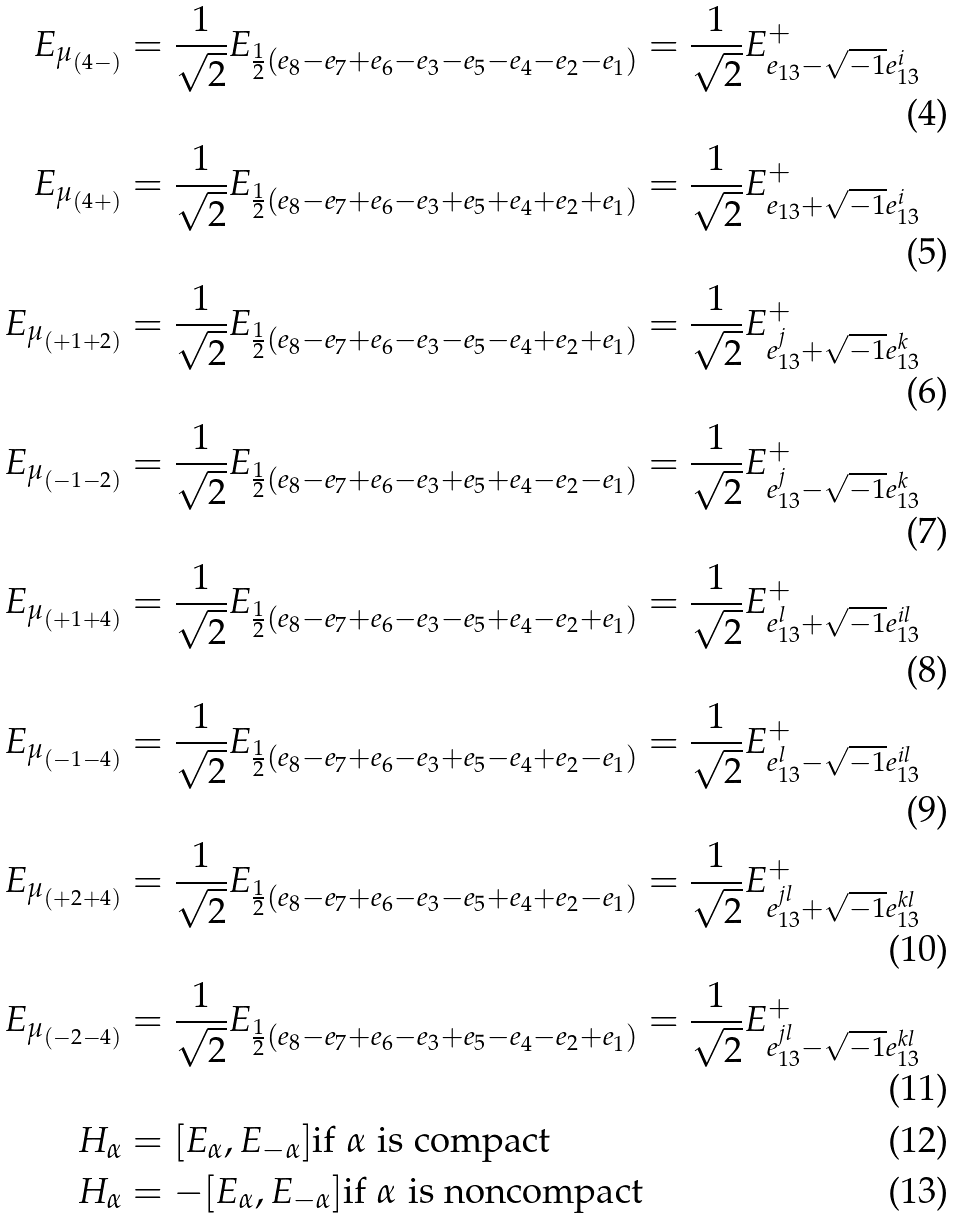<formula> <loc_0><loc_0><loc_500><loc_500>E _ { \mu _ { ( 4 - ) } } & = \frac { 1 } { \sqrt { 2 } } E _ { \frac { 1 } { 2 } ( e _ { 8 } - e _ { 7 } + e _ { 6 } - e _ { 3 } - e _ { 5 } - e _ { 4 } - e _ { 2 } - e _ { 1 } ) } = \frac { 1 } { \sqrt { 2 } } E _ { e _ { 1 3 } - \sqrt { - 1 } e _ { 1 3 } ^ { i } } ^ { + } \\ E _ { \mu _ { ( 4 + ) } } & = \frac { 1 } { \sqrt { 2 } } E _ { \frac { 1 } { 2 } ( e _ { 8 } - e _ { 7 } + e _ { 6 } - e _ { 3 } + e _ { 5 } + e _ { 4 } + e _ { 2 } + e _ { 1 } ) } = \frac { 1 } { \sqrt { 2 } } E _ { e _ { 1 3 } + \sqrt { - 1 } e _ { 1 3 } ^ { i } } ^ { + } \\ E _ { \mu _ { ( + 1 + 2 ) } } & = \frac { 1 } { \sqrt { 2 } } E _ { \frac { 1 } { 2 } ( e _ { 8 } - e _ { 7 } + e _ { 6 } - e _ { 3 } - e _ { 5 } - e _ { 4 } + e _ { 2 } + e _ { 1 } ) } = \frac { 1 } { \sqrt { 2 } } E _ { e _ { 1 3 } ^ { j } + \sqrt { - 1 } e _ { 1 3 } ^ { k } } ^ { + } \\ E _ { \mu _ { ( - 1 - 2 ) } } & = \frac { 1 } { \sqrt { 2 } } E _ { \frac { 1 } { 2 } ( e _ { 8 } - e _ { 7 } + e _ { 6 } - e _ { 3 } + e _ { 5 } + e _ { 4 } - e _ { 2 } - e _ { 1 } ) } = \frac { 1 } { \sqrt { 2 } } E _ { e _ { 1 3 } ^ { j } - \sqrt { - 1 } e _ { 1 3 } ^ { k } } ^ { + } \\ E _ { \mu _ { ( + 1 + 4 ) } } & = \frac { 1 } { \sqrt { 2 } } E _ { \frac { 1 } { 2 } ( e _ { 8 } - e _ { 7 } + e _ { 6 } - e _ { 3 } - e _ { 5 } + e _ { 4 } - e _ { 2 } + e _ { 1 } ) } = \frac { 1 } { \sqrt { 2 } } E _ { e _ { 1 3 } ^ { l } + \sqrt { - 1 } e _ { 1 3 } ^ { i l } } ^ { + } \\ E _ { \mu _ { ( - 1 - 4 ) } } & = \frac { 1 } { \sqrt { 2 } } E _ { \frac { 1 } { 2 } ( e _ { 8 } - e _ { 7 } + e _ { 6 } - e _ { 3 } + e _ { 5 } - e _ { 4 } + e _ { 2 } - e _ { 1 } ) } = \frac { 1 } { \sqrt { 2 } } E _ { e _ { 1 3 } ^ { l } - \sqrt { - 1 } e _ { 1 3 } ^ { i l } } ^ { + } \\ E _ { \mu _ { ( + 2 + 4 ) } } & = \frac { 1 } { \sqrt { 2 } } E _ { \frac { 1 } { 2 } ( e _ { 8 } - e _ { 7 } + e _ { 6 } - e _ { 3 } - e _ { 5 } + e _ { 4 } + e _ { 2 } - e _ { 1 } ) } = \frac { 1 } { \sqrt { 2 } } E _ { e _ { 1 3 } ^ { j l } + \sqrt { - 1 } e _ { 1 3 } ^ { k l } } ^ { + } \\ E _ { \mu _ { ( - 2 - 4 ) } } & = \frac { 1 } { \sqrt { 2 } } E _ { \frac { 1 } { 2 } ( e _ { 8 } - e _ { 7 } + e _ { 6 } - e _ { 3 } + e _ { 5 } - e _ { 4 } - e _ { 2 } + e _ { 1 } ) } = \frac { 1 } { \sqrt { 2 } } E _ { e _ { 1 3 } ^ { j l } - \sqrt { - 1 } e _ { 1 3 } ^ { k l } } ^ { + } \\ H _ { \alpha } & = [ E _ { \alpha } , E _ { - \alpha } ] \text {if $\alpha$ is compact} \\ H _ { \alpha } & = - [ E _ { \alpha } , E _ { - \alpha } ] \text {if $\alpha$ is noncompact}</formula> 